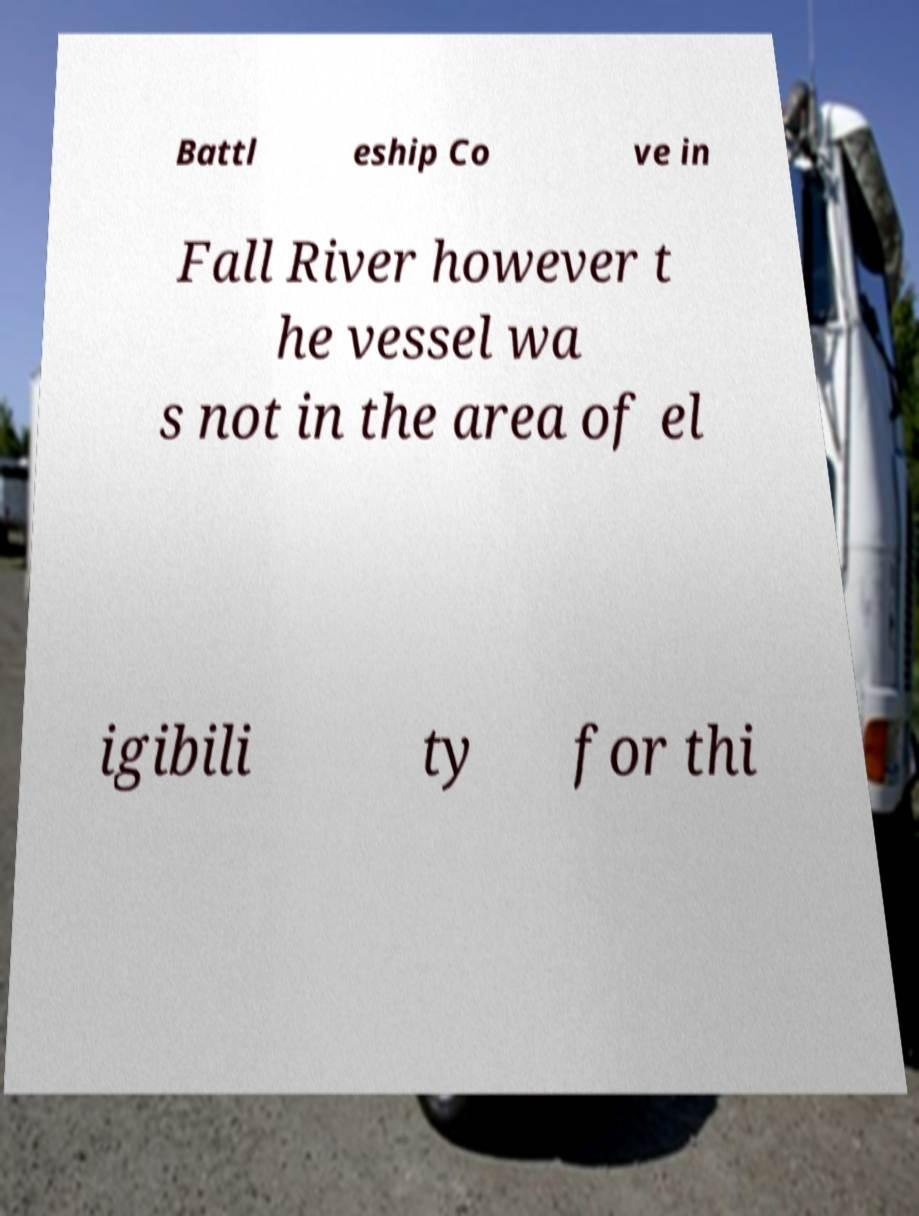Could you assist in decoding the text presented in this image and type it out clearly? Battl eship Co ve in Fall River however t he vessel wa s not in the area of el igibili ty for thi 